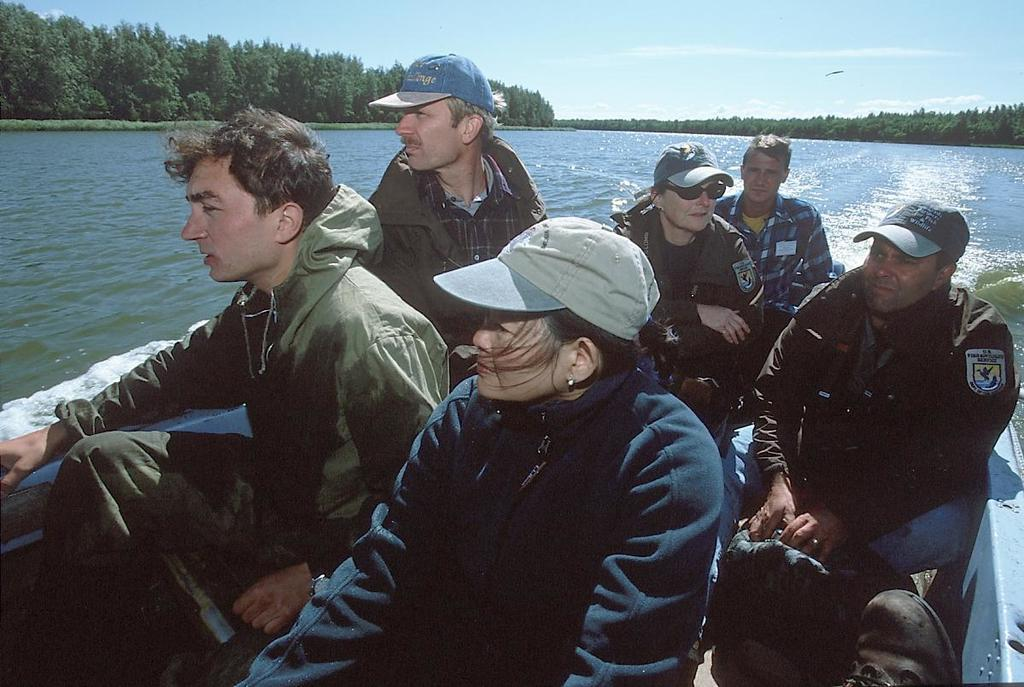What are the persons in the image doing? The persons in the image are sitting on a boat. What can be seen in the background of the image? There is water and trees visible in the background of the image. How would you describe the weather in the image? The sky is cloudy in the image, suggesting a potentially overcast or rainy day. Where is the train station located in the image? There is no train station present in the image; it features a boat on water with persons sitting on it. What type of game are the persons playing in the image? There is no game or play activity depicted in the image; the persons are simply sitting on a boat. 